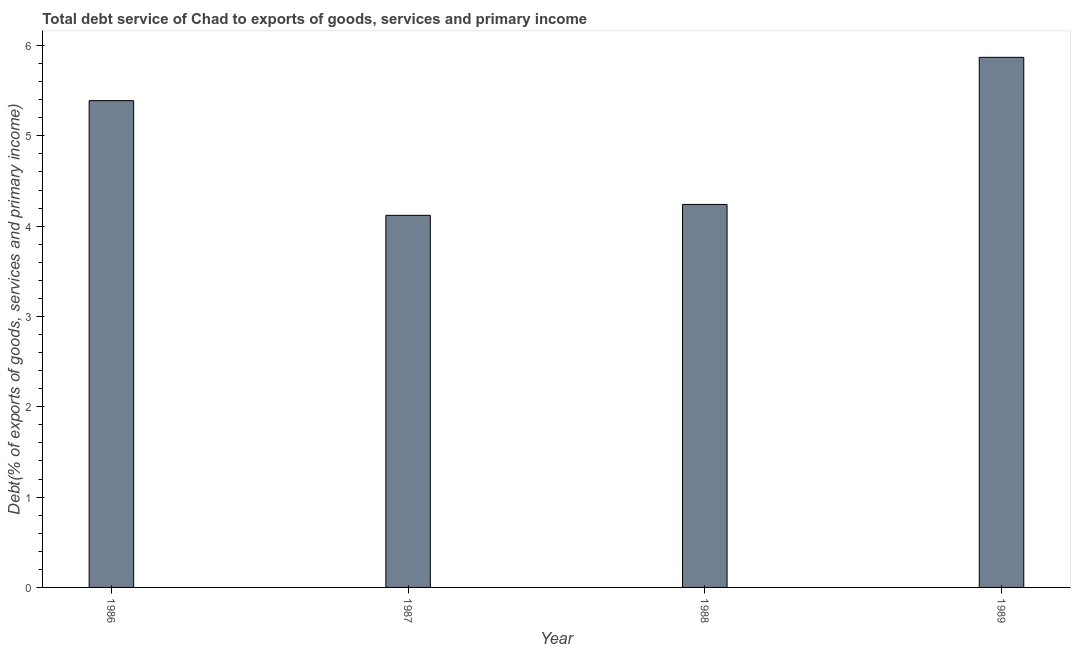Does the graph contain grids?
Offer a very short reply. No. What is the title of the graph?
Your response must be concise. Total debt service of Chad to exports of goods, services and primary income. What is the label or title of the X-axis?
Offer a very short reply. Year. What is the label or title of the Y-axis?
Make the answer very short. Debt(% of exports of goods, services and primary income). What is the total debt service in 1986?
Provide a short and direct response. 5.39. Across all years, what is the maximum total debt service?
Your answer should be very brief. 5.87. Across all years, what is the minimum total debt service?
Your answer should be very brief. 4.12. In which year was the total debt service maximum?
Provide a succinct answer. 1989. In which year was the total debt service minimum?
Your answer should be very brief. 1987. What is the sum of the total debt service?
Give a very brief answer. 19.62. What is the difference between the total debt service in 1987 and 1989?
Provide a short and direct response. -1.75. What is the average total debt service per year?
Provide a succinct answer. 4.91. What is the median total debt service?
Keep it short and to the point. 4.81. What is the ratio of the total debt service in 1988 to that in 1989?
Keep it short and to the point. 0.72. Is the difference between the total debt service in 1987 and 1988 greater than the difference between any two years?
Offer a very short reply. No. What is the difference between the highest and the second highest total debt service?
Your answer should be compact. 0.48. What is the difference between the highest and the lowest total debt service?
Provide a short and direct response. 1.75. In how many years, is the total debt service greater than the average total debt service taken over all years?
Make the answer very short. 2. What is the Debt(% of exports of goods, services and primary income) in 1986?
Offer a terse response. 5.39. What is the Debt(% of exports of goods, services and primary income) of 1987?
Offer a very short reply. 4.12. What is the Debt(% of exports of goods, services and primary income) in 1988?
Offer a terse response. 4.24. What is the Debt(% of exports of goods, services and primary income) in 1989?
Offer a terse response. 5.87. What is the difference between the Debt(% of exports of goods, services and primary income) in 1986 and 1987?
Your answer should be very brief. 1.27. What is the difference between the Debt(% of exports of goods, services and primary income) in 1986 and 1988?
Make the answer very short. 1.15. What is the difference between the Debt(% of exports of goods, services and primary income) in 1986 and 1989?
Give a very brief answer. -0.48. What is the difference between the Debt(% of exports of goods, services and primary income) in 1987 and 1988?
Ensure brevity in your answer.  -0.12. What is the difference between the Debt(% of exports of goods, services and primary income) in 1987 and 1989?
Give a very brief answer. -1.75. What is the difference between the Debt(% of exports of goods, services and primary income) in 1988 and 1989?
Offer a very short reply. -1.63. What is the ratio of the Debt(% of exports of goods, services and primary income) in 1986 to that in 1987?
Provide a succinct answer. 1.31. What is the ratio of the Debt(% of exports of goods, services and primary income) in 1986 to that in 1988?
Offer a terse response. 1.27. What is the ratio of the Debt(% of exports of goods, services and primary income) in 1986 to that in 1989?
Your answer should be very brief. 0.92. What is the ratio of the Debt(% of exports of goods, services and primary income) in 1987 to that in 1988?
Your answer should be very brief. 0.97. What is the ratio of the Debt(% of exports of goods, services and primary income) in 1987 to that in 1989?
Ensure brevity in your answer.  0.7. What is the ratio of the Debt(% of exports of goods, services and primary income) in 1988 to that in 1989?
Provide a succinct answer. 0.72. 